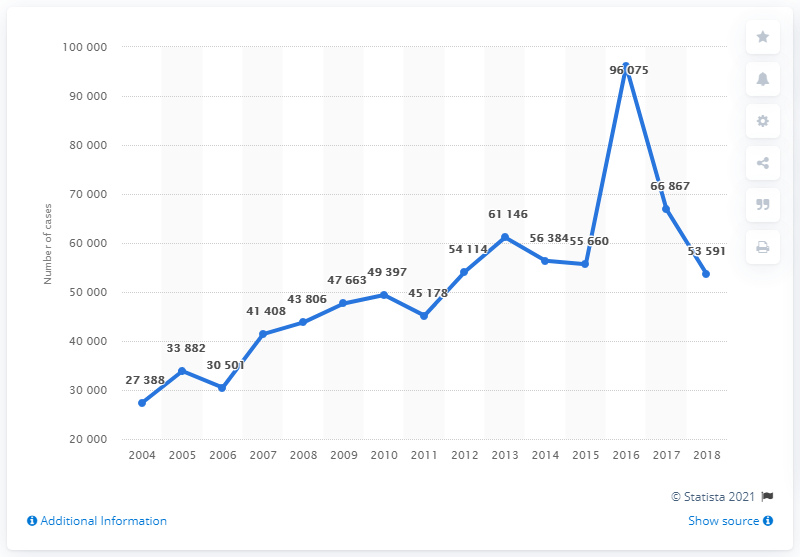Give some essential details in this illustration. The number of cases in the year 2005 is greater than 2006. In 2016, the number of cases was 96,075. 